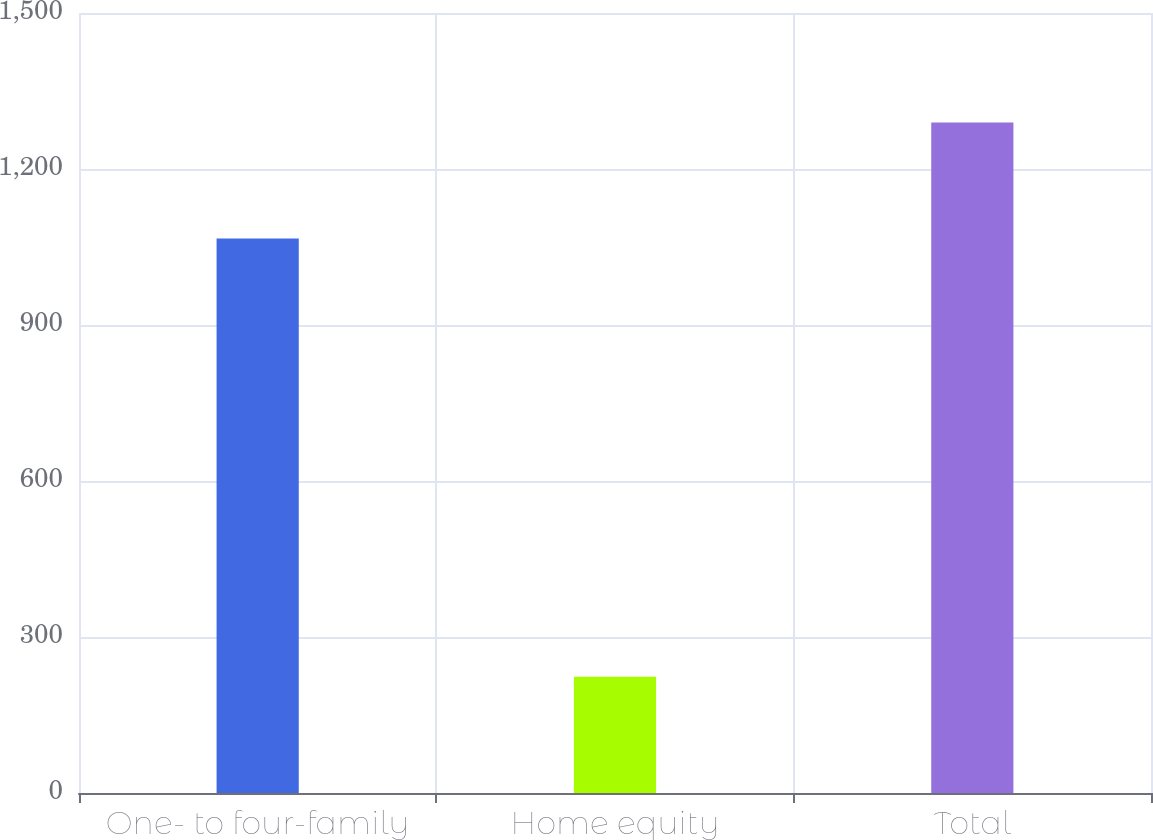<chart> <loc_0><loc_0><loc_500><loc_500><bar_chart><fcel>One- to four-family<fcel>Home equity<fcel>Total<nl><fcel>1066.2<fcel>223.4<fcel>1289.6<nl></chart> 